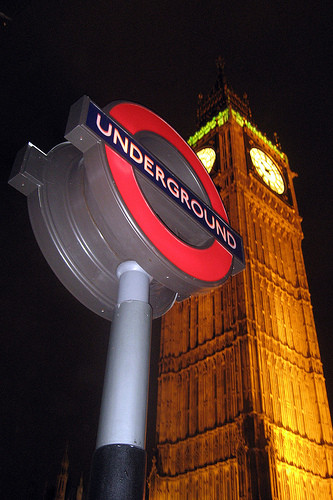<image>
Is there a sign behind the clock tower? No. The sign is not behind the clock tower. From this viewpoint, the sign appears to be positioned elsewhere in the scene. 